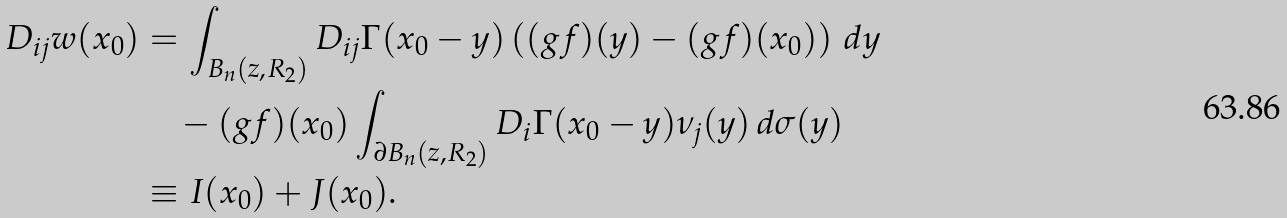<formula> <loc_0><loc_0><loc_500><loc_500>D _ { i j } w ( x _ { 0 } ) & = \int _ { B _ { n } ( z , R _ { 2 } ) } D _ { i j } \Gamma ( x _ { 0 } - y ) \left ( ( g f ) ( y ) - ( g f ) ( x _ { 0 } ) \right ) \, d y \\ & \quad - ( g f ) ( x _ { 0 } ) \int _ { \partial B _ { n } ( z , R _ { 2 } ) } D _ { i } \Gamma ( x _ { 0 } - y ) \nu _ { j } ( y ) \, d \sigma ( y ) \\ & \equiv I ( x _ { 0 } ) + J ( x _ { 0 } ) .</formula> 